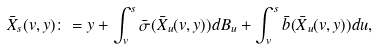Convert formula to latex. <formula><loc_0><loc_0><loc_500><loc_500>\bar { X } _ { s } ( v , y ) \colon = y + \int _ { v } ^ { s } \bar { \sigma } ( \bar { X } _ { u } ( v , y ) ) d B _ { u } + \int _ { v } ^ { s } \bar { b } ( \bar { X } _ { u } ( v , y ) ) d u ,</formula> 